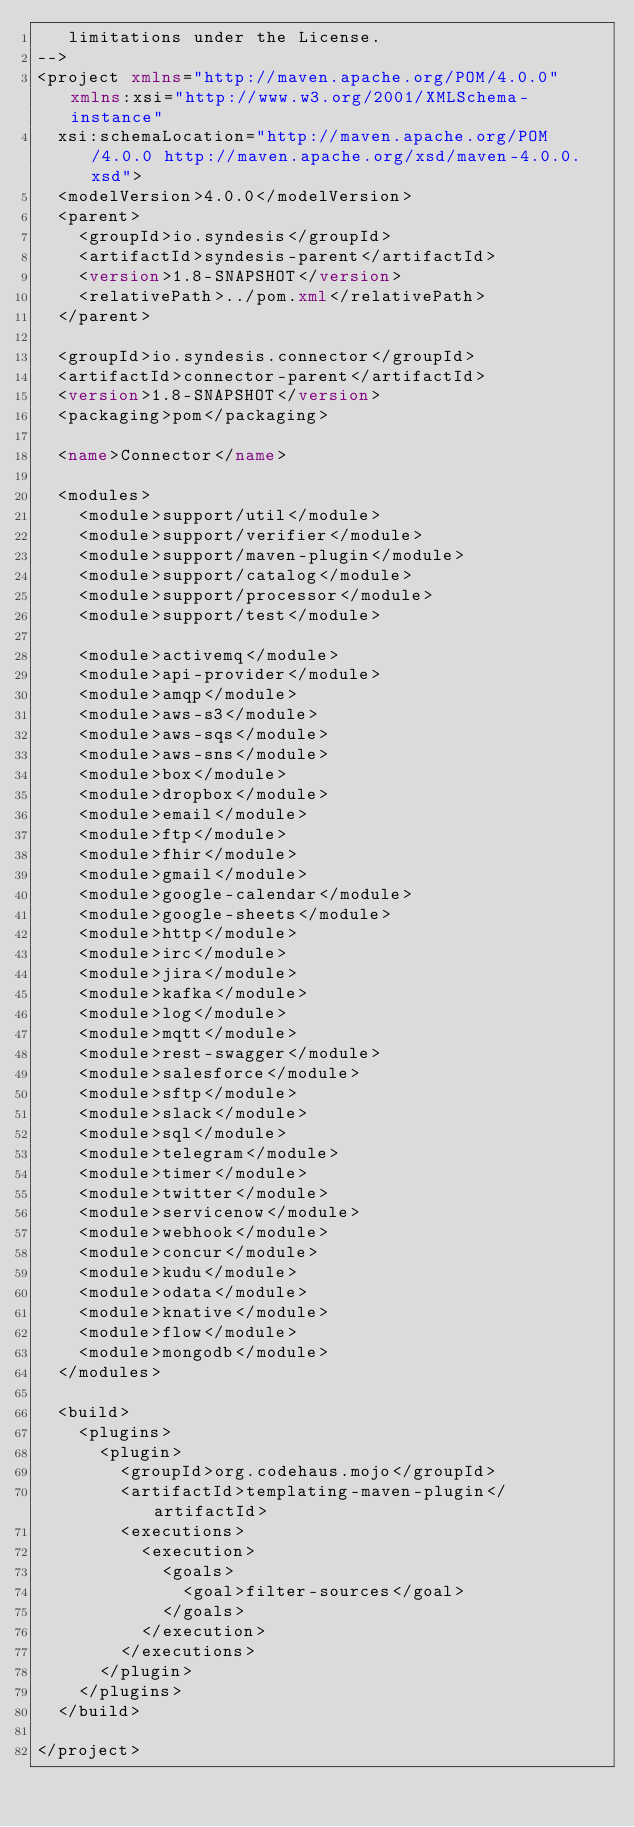Convert code to text. <code><loc_0><loc_0><loc_500><loc_500><_XML_>   limitations under the License.
-->
<project xmlns="http://maven.apache.org/POM/4.0.0" xmlns:xsi="http://www.w3.org/2001/XMLSchema-instance"
  xsi:schemaLocation="http://maven.apache.org/POM/4.0.0 http://maven.apache.org/xsd/maven-4.0.0.xsd">
  <modelVersion>4.0.0</modelVersion>
  <parent>
    <groupId>io.syndesis</groupId>
    <artifactId>syndesis-parent</artifactId>
    <version>1.8-SNAPSHOT</version>
    <relativePath>../pom.xml</relativePath>
  </parent>

  <groupId>io.syndesis.connector</groupId>
  <artifactId>connector-parent</artifactId>
  <version>1.8-SNAPSHOT</version>
  <packaging>pom</packaging>

  <name>Connector</name>

  <modules>
    <module>support/util</module>
    <module>support/verifier</module>
    <module>support/maven-plugin</module>
    <module>support/catalog</module>
    <module>support/processor</module>
    <module>support/test</module>

    <module>activemq</module>
    <module>api-provider</module>
    <module>amqp</module>
    <module>aws-s3</module>
    <module>aws-sqs</module>
    <module>aws-sns</module>
    <module>box</module>
    <module>dropbox</module>
    <module>email</module>
    <module>ftp</module>
    <module>fhir</module>
    <module>gmail</module>
    <module>google-calendar</module>
    <module>google-sheets</module>
    <module>http</module>
    <module>irc</module>
    <module>jira</module>
    <module>kafka</module>
    <module>log</module>
    <module>mqtt</module>
    <module>rest-swagger</module>
    <module>salesforce</module>
    <module>sftp</module>
    <module>slack</module>
    <module>sql</module>
    <module>telegram</module>
    <module>timer</module>
    <module>twitter</module>
    <module>servicenow</module>
    <module>webhook</module>
    <module>concur</module>
    <module>kudu</module>
    <module>odata</module>
    <module>knative</module>
    <module>flow</module>
    <module>mongodb</module>
  </modules>

  <build>
    <plugins>
      <plugin>
        <groupId>org.codehaus.mojo</groupId>
        <artifactId>templating-maven-plugin</artifactId>
        <executions>
          <execution>
            <goals>
              <goal>filter-sources</goal>
            </goals>
          </execution>
        </executions>
      </plugin>
    </plugins>
  </build>

</project>
</code> 